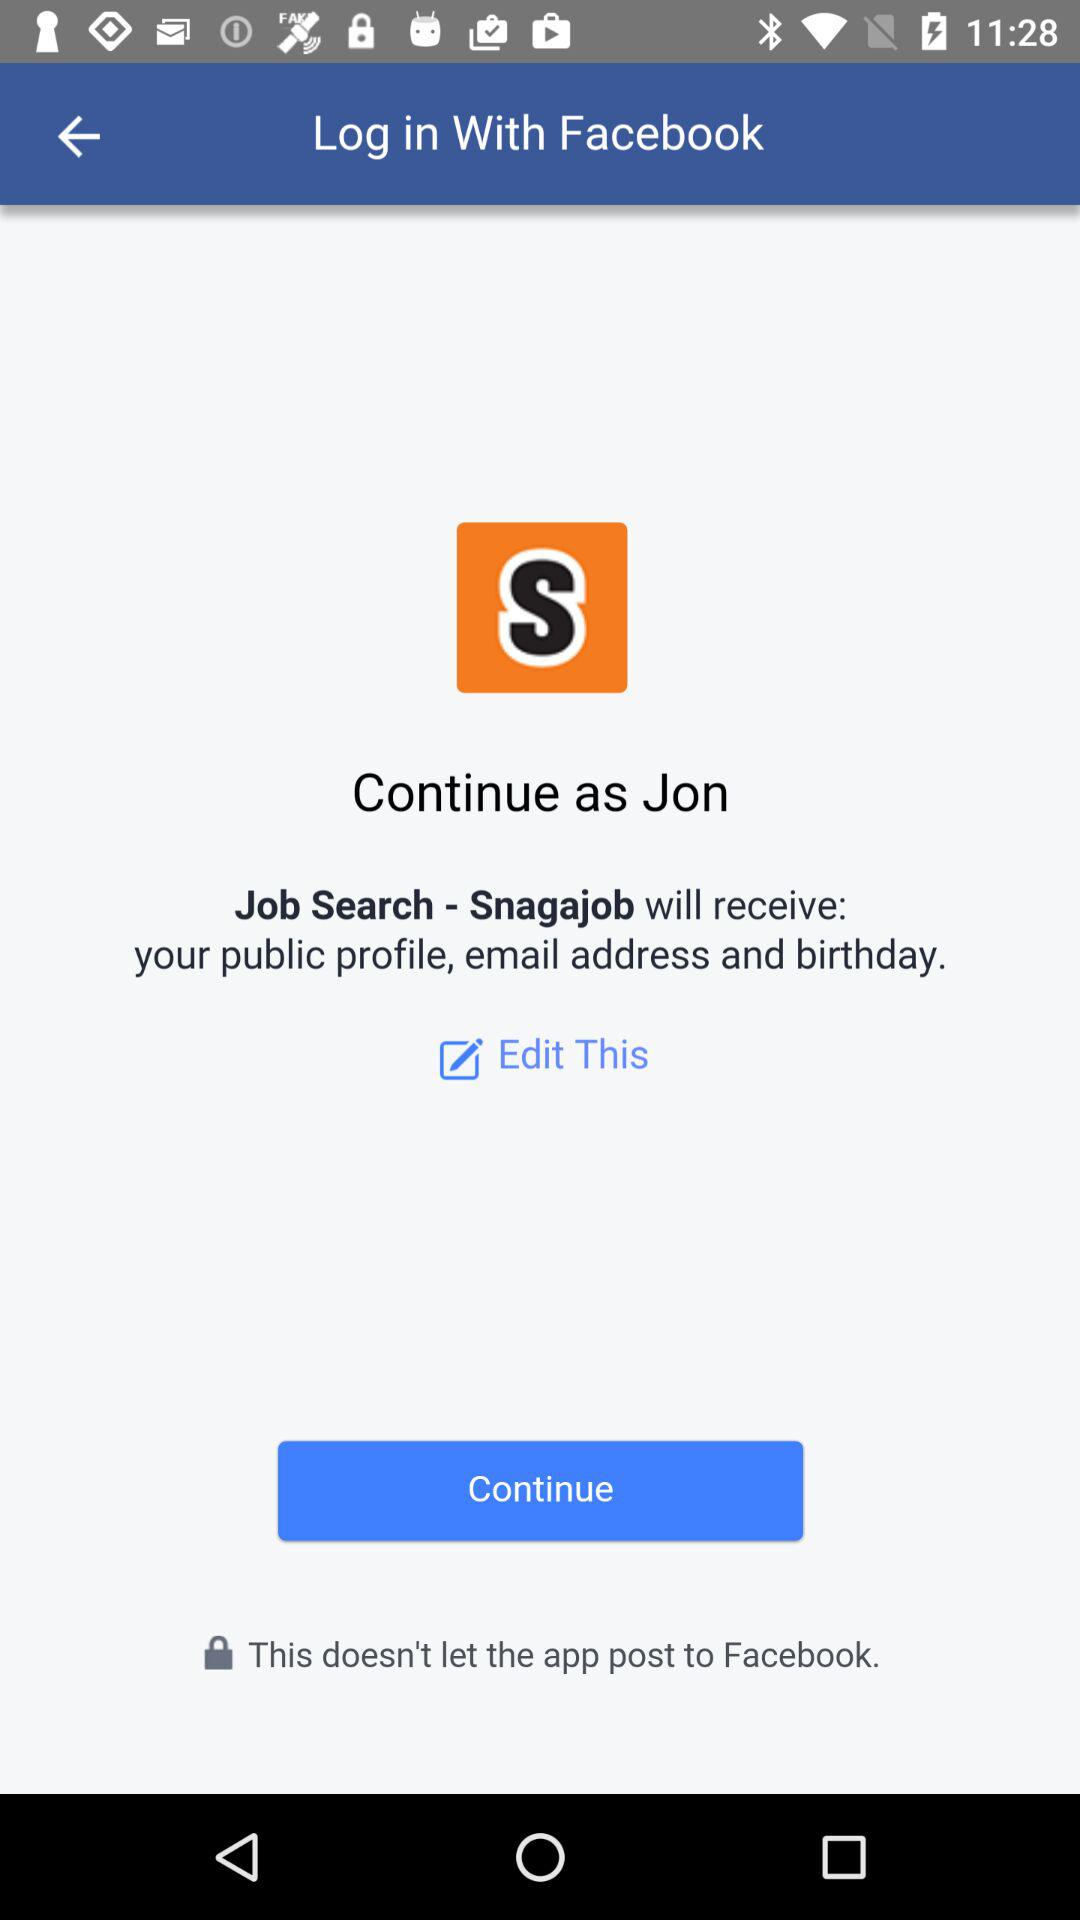Through what application can the user log in? The user can log in through the "Facebook" application. 